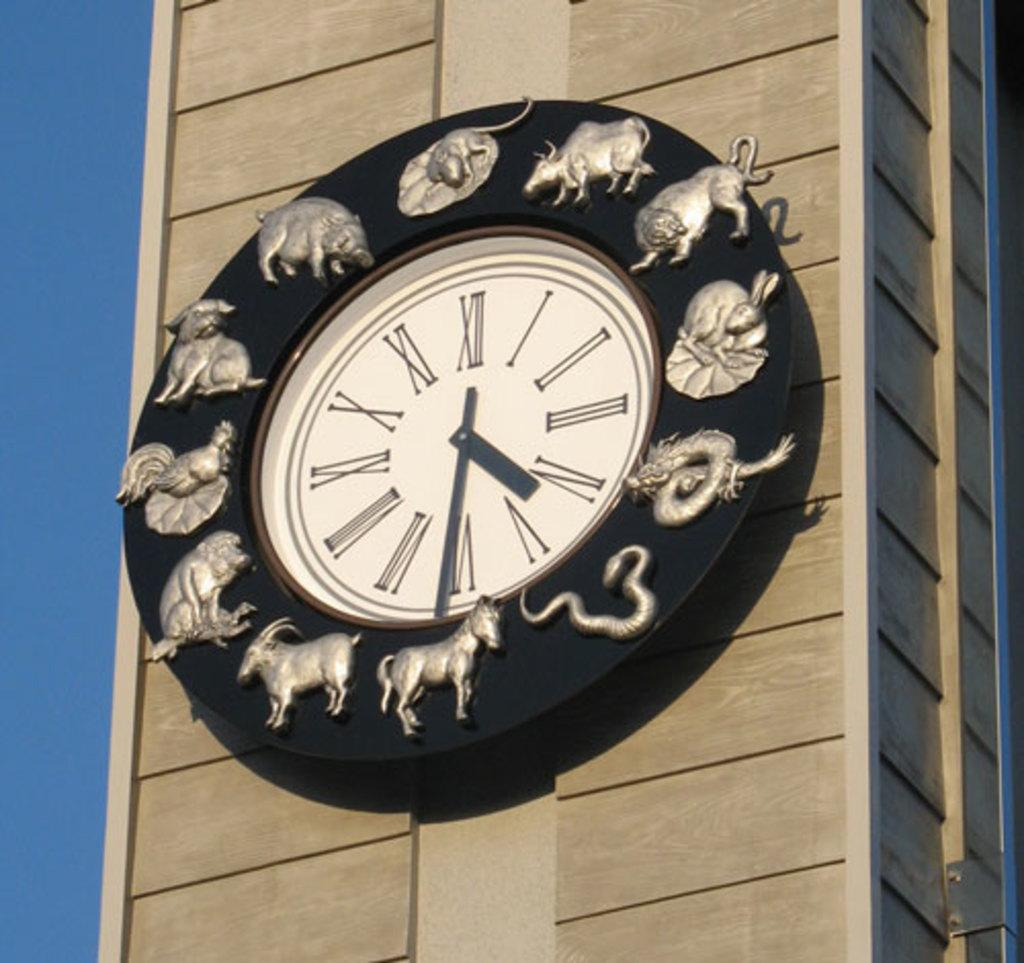What is the main subject in the center of the image? There is a clock on a tower in the center of the image. What can be seen in the background of the image? There is a sky visible in the background of the image. How many pencils can be seen floating in the sky in the image? There are no pencils visible in the sky in the image. What type of boats are present in the image? There are no boats present in the image. 